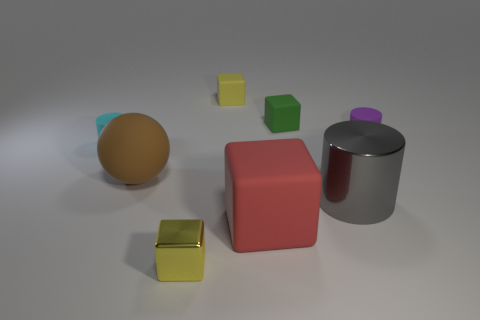Subtract 1 cubes. How many cubes are left? 3 Add 2 metal objects. How many objects exist? 10 Subtract all spheres. How many objects are left? 7 Add 4 small cyan rubber things. How many small cyan rubber things exist? 5 Subtract 0 purple balls. How many objects are left? 8 Subtract all brown objects. Subtract all small yellow metal objects. How many objects are left? 6 Add 6 cyan matte cylinders. How many cyan matte cylinders are left? 7 